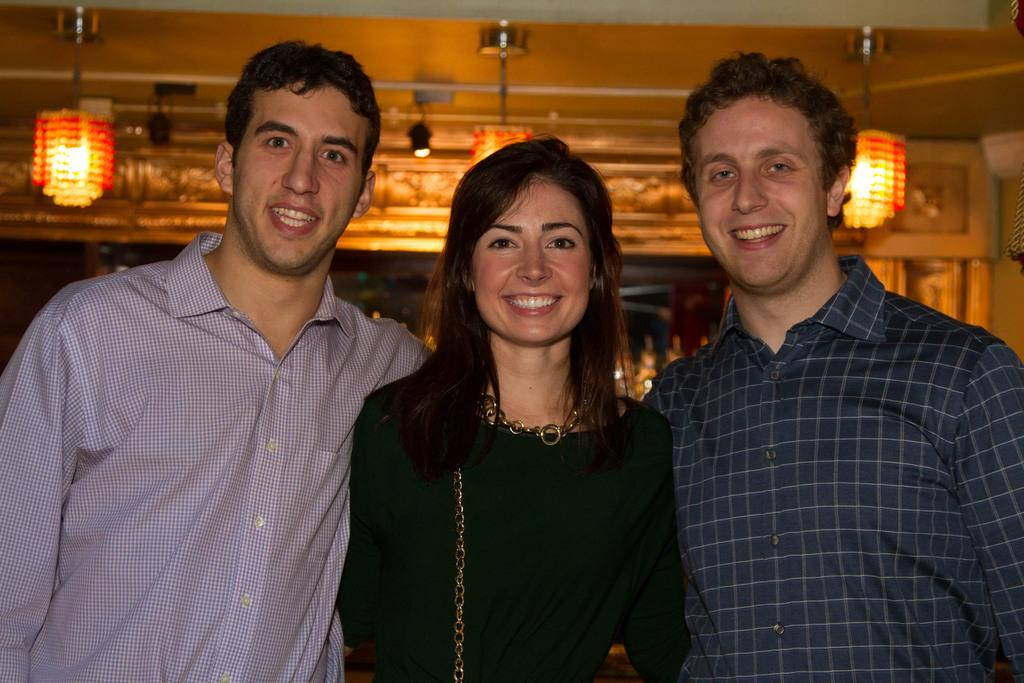How many people are in the image? There are two men and one woman in the image, making a total of three people. What are the people in the image doing? The people are standing and smiling. What type of lighting is present in the image? There are lamps hanging from the roof, providing light. What can be seen in the background of the image? There is an arch in the background of the image. What type of straw is being used to drink milk in the image? There is no straw or milk present in the image; it features two men and one woman standing and smiling. 